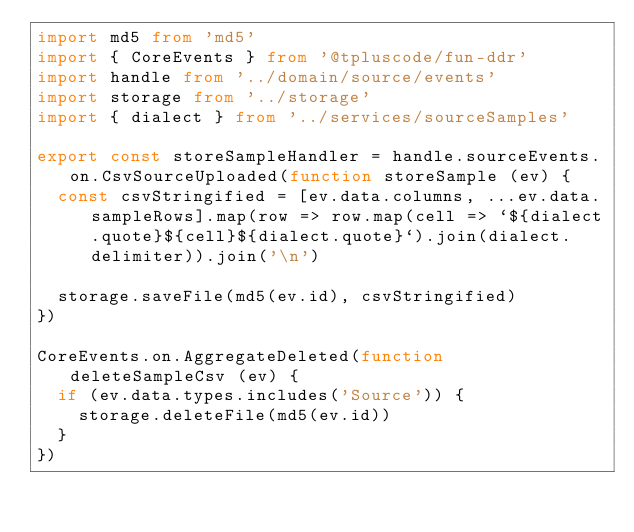Convert code to text. <code><loc_0><loc_0><loc_500><loc_500><_TypeScript_>import md5 from 'md5'
import { CoreEvents } from '@tpluscode/fun-ddr'
import handle from '../domain/source/events'
import storage from '../storage'
import { dialect } from '../services/sourceSamples'

export const storeSampleHandler = handle.sourceEvents.on.CsvSourceUploaded(function storeSample (ev) {
  const csvStringified = [ev.data.columns, ...ev.data.sampleRows].map(row => row.map(cell => `${dialect.quote}${cell}${dialect.quote}`).join(dialect.delimiter)).join('\n')

  storage.saveFile(md5(ev.id), csvStringified)
})

CoreEvents.on.AggregateDeleted(function deleteSampleCsv (ev) {
  if (ev.data.types.includes('Source')) {
    storage.deleteFile(md5(ev.id))
  }
})
</code> 